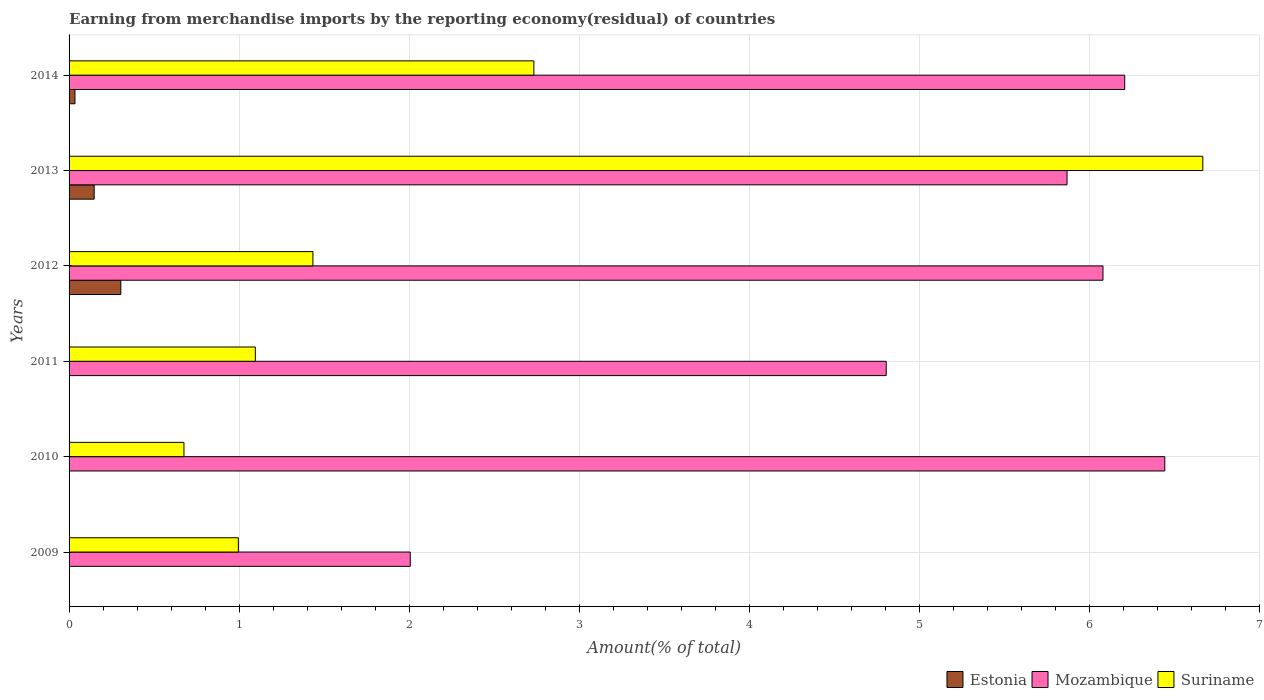How many different coloured bars are there?
Make the answer very short. 3. How many groups of bars are there?
Offer a very short reply. 6. Are the number of bars on each tick of the Y-axis equal?
Make the answer very short. Yes. What is the percentage of amount earned from merchandise imports in Estonia in 2009?
Provide a succinct answer. 0. Across all years, what is the maximum percentage of amount earned from merchandise imports in Suriname?
Provide a succinct answer. 6.67. Across all years, what is the minimum percentage of amount earned from merchandise imports in Suriname?
Give a very brief answer. 0.68. In which year was the percentage of amount earned from merchandise imports in Estonia maximum?
Offer a terse response. 2012. What is the total percentage of amount earned from merchandise imports in Mozambique in the graph?
Offer a very short reply. 31.42. What is the difference between the percentage of amount earned from merchandise imports in Suriname in 2010 and that in 2013?
Provide a short and direct response. -5.99. What is the difference between the percentage of amount earned from merchandise imports in Mozambique in 2010 and the percentage of amount earned from merchandise imports in Suriname in 2012?
Provide a short and direct response. 5.01. What is the average percentage of amount earned from merchandise imports in Estonia per year?
Provide a succinct answer. 0.08. In the year 2013, what is the difference between the percentage of amount earned from merchandise imports in Suriname and percentage of amount earned from merchandise imports in Mozambique?
Provide a succinct answer. 0.8. What is the ratio of the percentage of amount earned from merchandise imports in Suriname in 2009 to that in 2013?
Keep it short and to the point. 0.15. What is the difference between the highest and the second highest percentage of amount earned from merchandise imports in Estonia?
Give a very brief answer. 0.16. What is the difference between the highest and the lowest percentage of amount earned from merchandise imports in Mozambique?
Offer a very short reply. 4.44. In how many years, is the percentage of amount earned from merchandise imports in Mozambique greater than the average percentage of amount earned from merchandise imports in Mozambique taken over all years?
Offer a very short reply. 4. What does the 2nd bar from the top in 2014 represents?
Ensure brevity in your answer.  Mozambique. What does the 1st bar from the bottom in 2011 represents?
Offer a terse response. Estonia. Is it the case that in every year, the sum of the percentage of amount earned from merchandise imports in Estonia and percentage of amount earned from merchandise imports in Suriname is greater than the percentage of amount earned from merchandise imports in Mozambique?
Offer a terse response. No. How many bars are there?
Offer a terse response. 18. Are all the bars in the graph horizontal?
Ensure brevity in your answer.  Yes. How many years are there in the graph?
Offer a terse response. 6. What is the difference between two consecutive major ticks on the X-axis?
Your answer should be very brief. 1. Does the graph contain grids?
Offer a terse response. Yes. How many legend labels are there?
Ensure brevity in your answer.  3. What is the title of the graph?
Ensure brevity in your answer.  Earning from merchandise imports by the reporting economy(residual) of countries. Does "Barbados" appear as one of the legend labels in the graph?
Offer a terse response. No. What is the label or title of the X-axis?
Offer a terse response. Amount(% of total). What is the Amount(% of total) of Estonia in 2009?
Offer a terse response. 0. What is the Amount(% of total) in Mozambique in 2009?
Keep it short and to the point. 2.01. What is the Amount(% of total) in Suriname in 2009?
Provide a short and direct response. 1. What is the Amount(% of total) in Estonia in 2010?
Your answer should be very brief. 2.66567306426196e-5. What is the Amount(% of total) of Mozambique in 2010?
Ensure brevity in your answer.  6.45. What is the Amount(% of total) of Suriname in 2010?
Make the answer very short. 0.68. What is the Amount(% of total) in Estonia in 2011?
Offer a very short reply. 0. What is the Amount(% of total) in Mozambique in 2011?
Your answer should be compact. 4.81. What is the Amount(% of total) of Suriname in 2011?
Ensure brevity in your answer.  1.1. What is the Amount(% of total) of Estonia in 2012?
Your answer should be very brief. 0.3. What is the Amount(% of total) in Mozambique in 2012?
Offer a terse response. 6.08. What is the Amount(% of total) of Suriname in 2012?
Keep it short and to the point. 1.43. What is the Amount(% of total) of Estonia in 2013?
Provide a short and direct response. 0.15. What is the Amount(% of total) in Mozambique in 2013?
Provide a short and direct response. 5.87. What is the Amount(% of total) in Suriname in 2013?
Make the answer very short. 6.67. What is the Amount(% of total) in Estonia in 2014?
Offer a terse response. 0.03. What is the Amount(% of total) of Mozambique in 2014?
Keep it short and to the point. 6.21. What is the Amount(% of total) in Suriname in 2014?
Your answer should be compact. 2.73. Across all years, what is the maximum Amount(% of total) of Estonia?
Offer a very short reply. 0.3. Across all years, what is the maximum Amount(% of total) of Mozambique?
Your answer should be compact. 6.45. Across all years, what is the maximum Amount(% of total) of Suriname?
Your answer should be compact. 6.67. Across all years, what is the minimum Amount(% of total) in Estonia?
Offer a terse response. 2.66567306426196e-5. Across all years, what is the minimum Amount(% of total) of Mozambique?
Your answer should be very brief. 2.01. Across all years, what is the minimum Amount(% of total) of Suriname?
Ensure brevity in your answer.  0.68. What is the total Amount(% of total) in Estonia in the graph?
Your response must be concise. 0.49. What is the total Amount(% of total) in Mozambique in the graph?
Keep it short and to the point. 31.42. What is the total Amount(% of total) of Suriname in the graph?
Your response must be concise. 13.61. What is the difference between the Amount(% of total) in Mozambique in 2009 and that in 2010?
Make the answer very short. -4.44. What is the difference between the Amount(% of total) in Suriname in 2009 and that in 2010?
Your answer should be compact. 0.32. What is the difference between the Amount(% of total) of Mozambique in 2009 and that in 2011?
Provide a succinct answer. -2.8. What is the difference between the Amount(% of total) of Suriname in 2009 and that in 2011?
Your response must be concise. -0.1. What is the difference between the Amount(% of total) in Estonia in 2009 and that in 2012?
Offer a terse response. -0.3. What is the difference between the Amount(% of total) in Mozambique in 2009 and that in 2012?
Offer a terse response. -4.07. What is the difference between the Amount(% of total) in Suriname in 2009 and that in 2012?
Keep it short and to the point. -0.44. What is the difference between the Amount(% of total) in Estonia in 2009 and that in 2013?
Provide a succinct answer. -0.15. What is the difference between the Amount(% of total) of Mozambique in 2009 and that in 2013?
Offer a terse response. -3.86. What is the difference between the Amount(% of total) of Suriname in 2009 and that in 2013?
Make the answer very short. -5.67. What is the difference between the Amount(% of total) of Estonia in 2009 and that in 2014?
Give a very brief answer. -0.03. What is the difference between the Amount(% of total) of Mozambique in 2009 and that in 2014?
Make the answer very short. -4.2. What is the difference between the Amount(% of total) of Suriname in 2009 and that in 2014?
Make the answer very short. -1.74. What is the difference between the Amount(% of total) of Estonia in 2010 and that in 2011?
Offer a very short reply. -0. What is the difference between the Amount(% of total) of Mozambique in 2010 and that in 2011?
Offer a very short reply. 1.64. What is the difference between the Amount(% of total) of Suriname in 2010 and that in 2011?
Your answer should be compact. -0.42. What is the difference between the Amount(% of total) of Estonia in 2010 and that in 2012?
Give a very brief answer. -0.3. What is the difference between the Amount(% of total) of Mozambique in 2010 and that in 2012?
Offer a very short reply. 0.36. What is the difference between the Amount(% of total) of Suriname in 2010 and that in 2012?
Provide a succinct answer. -0.76. What is the difference between the Amount(% of total) in Estonia in 2010 and that in 2013?
Keep it short and to the point. -0.15. What is the difference between the Amount(% of total) in Mozambique in 2010 and that in 2013?
Your answer should be very brief. 0.58. What is the difference between the Amount(% of total) in Suriname in 2010 and that in 2013?
Keep it short and to the point. -5.99. What is the difference between the Amount(% of total) of Estonia in 2010 and that in 2014?
Provide a succinct answer. -0.03. What is the difference between the Amount(% of total) of Mozambique in 2010 and that in 2014?
Provide a short and direct response. 0.24. What is the difference between the Amount(% of total) in Suriname in 2010 and that in 2014?
Make the answer very short. -2.06. What is the difference between the Amount(% of total) of Estonia in 2011 and that in 2012?
Offer a terse response. -0.3. What is the difference between the Amount(% of total) in Mozambique in 2011 and that in 2012?
Your response must be concise. -1.28. What is the difference between the Amount(% of total) in Suriname in 2011 and that in 2012?
Make the answer very short. -0.34. What is the difference between the Amount(% of total) of Estonia in 2011 and that in 2013?
Your response must be concise. -0.15. What is the difference between the Amount(% of total) of Mozambique in 2011 and that in 2013?
Keep it short and to the point. -1.06. What is the difference between the Amount(% of total) in Suriname in 2011 and that in 2013?
Offer a very short reply. -5.57. What is the difference between the Amount(% of total) of Estonia in 2011 and that in 2014?
Ensure brevity in your answer.  -0.03. What is the difference between the Amount(% of total) in Mozambique in 2011 and that in 2014?
Offer a very short reply. -1.4. What is the difference between the Amount(% of total) of Suriname in 2011 and that in 2014?
Your answer should be very brief. -1.64. What is the difference between the Amount(% of total) in Estonia in 2012 and that in 2013?
Offer a very short reply. 0.16. What is the difference between the Amount(% of total) in Mozambique in 2012 and that in 2013?
Keep it short and to the point. 0.21. What is the difference between the Amount(% of total) of Suriname in 2012 and that in 2013?
Your answer should be very brief. -5.23. What is the difference between the Amount(% of total) in Estonia in 2012 and that in 2014?
Your answer should be compact. 0.27. What is the difference between the Amount(% of total) of Mozambique in 2012 and that in 2014?
Make the answer very short. -0.13. What is the difference between the Amount(% of total) of Suriname in 2012 and that in 2014?
Provide a succinct answer. -1.3. What is the difference between the Amount(% of total) in Estonia in 2013 and that in 2014?
Provide a succinct answer. 0.11. What is the difference between the Amount(% of total) in Mozambique in 2013 and that in 2014?
Your answer should be very brief. -0.34. What is the difference between the Amount(% of total) in Suriname in 2013 and that in 2014?
Ensure brevity in your answer.  3.94. What is the difference between the Amount(% of total) of Estonia in 2009 and the Amount(% of total) of Mozambique in 2010?
Keep it short and to the point. -6.45. What is the difference between the Amount(% of total) in Estonia in 2009 and the Amount(% of total) in Suriname in 2010?
Offer a terse response. -0.68. What is the difference between the Amount(% of total) of Mozambique in 2009 and the Amount(% of total) of Suriname in 2010?
Ensure brevity in your answer.  1.33. What is the difference between the Amount(% of total) in Estonia in 2009 and the Amount(% of total) in Mozambique in 2011?
Provide a succinct answer. -4.81. What is the difference between the Amount(% of total) in Estonia in 2009 and the Amount(% of total) in Suriname in 2011?
Offer a terse response. -1.1. What is the difference between the Amount(% of total) of Mozambique in 2009 and the Amount(% of total) of Suriname in 2011?
Ensure brevity in your answer.  0.91. What is the difference between the Amount(% of total) of Estonia in 2009 and the Amount(% of total) of Mozambique in 2012?
Give a very brief answer. -6.08. What is the difference between the Amount(% of total) of Estonia in 2009 and the Amount(% of total) of Suriname in 2012?
Offer a terse response. -1.43. What is the difference between the Amount(% of total) in Mozambique in 2009 and the Amount(% of total) in Suriname in 2012?
Make the answer very short. 0.57. What is the difference between the Amount(% of total) of Estonia in 2009 and the Amount(% of total) of Mozambique in 2013?
Offer a terse response. -5.87. What is the difference between the Amount(% of total) of Estonia in 2009 and the Amount(% of total) of Suriname in 2013?
Offer a very short reply. -6.67. What is the difference between the Amount(% of total) in Mozambique in 2009 and the Amount(% of total) in Suriname in 2013?
Your answer should be compact. -4.66. What is the difference between the Amount(% of total) in Estonia in 2009 and the Amount(% of total) in Mozambique in 2014?
Give a very brief answer. -6.21. What is the difference between the Amount(% of total) of Estonia in 2009 and the Amount(% of total) of Suriname in 2014?
Keep it short and to the point. -2.73. What is the difference between the Amount(% of total) in Mozambique in 2009 and the Amount(% of total) in Suriname in 2014?
Ensure brevity in your answer.  -0.73. What is the difference between the Amount(% of total) in Estonia in 2010 and the Amount(% of total) in Mozambique in 2011?
Keep it short and to the point. -4.81. What is the difference between the Amount(% of total) of Estonia in 2010 and the Amount(% of total) of Suriname in 2011?
Your answer should be compact. -1.1. What is the difference between the Amount(% of total) of Mozambique in 2010 and the Amount(% of total) of Suriname in 2011?
Offer a very short reply. 5.35. What is the difference between the Amount(% of total) in Estonia in 2010 and the Amount(% of total) in Mozambique in 2012?
Provide a short and direct response. -6.08. What is the difference between the Amount(% of total) of Estonia in 2010 and the Amount(% of total) of Suriname in 2012?
Give a very brief answer. -1.43. What is the difference between the Amount(% of total) of Mozambique in 2010 and the Amount(% of total) of Suriname in 2012?
Provide a short and direct response. 5.01. What is the difference between the Amount(% of total) in Estonia in 2010 and the Amount(% of total) in Mozambique in 2013?
Ensure brevity in your answer.  -5.87. What is the difference between the Amount(% of total) of Estonia in 2010 and the Amount(% of total) of Suriname in 2013?
Your response must be concise. -6.67. What is the difference between the Amount(% of total) in Mozambique in 2010 and the Amount(% of total) in Suriname in 2013?
Offer a very short reply. -0.22. What is the difference between the Amount(% of total) in Estonia in 2010 and the Amount(% of total) in Mozambique in 2014?
Provide a short and direct response. -6.21. What is the difference between the Amount(% of total) in Estonia in 2010 and the Amount(% of total) in Suriname in 2014?
Offer a very short reply. -2.73. What is the difference between the Amount(% of total) in Mozambique in 2010 and the Amount(% of total) in Suriname in 2014?
Provide a succinct answer. 3.71. What is the difference between the Amount(% of total) of Estonia in 2011 and the Amount(% of total) of Mozambique in 2012?
Ensure brevity in your answer.  -6.08. What is the difference between the Amount(% of total) in Estonia in 2011 and the Amount(% of total) in Suriname in 2012?
Your answer should be compact. -1.43. What is the difference between the Amount(% of total) in Mozambique in 2011 and the Amount(% of total) in Suriname in 2012?
Offer a terse response. 3.37. What is the difference between the Amount(% of total) of Estonia in 2011 and the Amount(% of total) of Mozambique in 2013?
Offer a very short reply. -5.87. What is the difference between the Amount(% of total) of Estonia in 2011 and the Amount(% of total) of Suriname in 2013?
Give a very brief answer. -6.67. What is the difference between the Amount(% of total) in Mozambique in 2011 and the Amount(% of total) in Suriname in 2013?
Ensure brevity in your answer.  -1.86. What is the difference between the Amount(% of total) of Estonia in 2011 and the Amount(% of total) of Mozambique in 2014?
Keep it short and to the point. -6.21. What is the difference between the Amount(% of total) of Estonia in 2011 and the Amount(% of total) of Suriname in 2014?
Offer a very short reply. -2.73. What is the difference between the Amount(% of total) of Mozambique in 2011 and the Amount(% of total) of Suriname in 2014?
Ensure brevity in your answer.  2.07. What is the difference between the Amount(% of total) in Estonia in 2012 and the Amount(% of total) in Mozambique in 2013?
Keep it short and to the point. -5.57. What is the difference between the Amount(% of total) of Estonia in 2012 and the Amount(% of total) of Suriname in 2013?
Provide a succinct answer. -6.36. What is the difference between the Amount(% of total) in Mozambique in 2012 and the Amount(% of total) in Suriname in 2013?
Provide a short and direct response. -0.59. What is the difference between the Amount(% of total) in Estonia in 2012 and the Amount(% of total) in Mozambique in 2014?
Ensure brevity in your answer.  -5.91. What is the difference between the Amount(% of total) of Estonia in 2012 and the Amount(% of total) of Suriname in 2014?
Keep it short and to the point. -2.43. What is the difference between the Amount(% of total) of Mozambique in 2012 and the Amount(% of total) of Suriname in 2014?
Give a very brief answer. 3.35. What is the difference between the Amount(% of total) of Estonia in 2013 and the Amount(% of total) of Mozambique in 2014?
Keep it short and to the point. -6.06. What is the difference between the Amount(% of total) of Estonia in 2013 and the Amount(% of total) of Suriname in 2014?
Offer a very short reply. -2.59. What is the difference between the Amount(% of total) in Mozambique in 2013 and the Amount(% of total) in Suriname in 2014?
Offer a terse response. 3.14. What is the average Amount(% of total) of Estonia per year?
Make the answer very short. 0.08. What is the average Amount(% of total) in Mozambique per year?
Provide a succinct answer. 5.24. What is the average Amount(% of total) of Suriname per year?
Provide a short and direct response. 2.27. In the year 2009, what is the difference between the Amount(% of total) of Estonia and Amount(% of total) of Mozambique?
Your answer should be compact. -2.01. In the year 2009, what is the difference between the Amount(% of total) in Estonia and Amount(% of total) in Suriname?
Offer a terse response. -1. In the year 2009, what is the difference between the Amount(% of total) of Mozambique and Amount(% of total) of Suriname?
Your answer should be compact. 1.01. In the year 2010, what is the difference between the Amount(% of total) in Estonia and Amount(% of total) in Mozambique?
Your answer should be compact. -6.45. In the year 2010, what is the difference between the Amount(% of total) in Estonia and Amount(% of total) in Suriname?
Provide a succinct answer. -0.68. In the year 2010, what is the difference between the Amount(% of total) of Mozambique and Amount(% of total) of Suriname?
Ensure brevity in your answer.  5.77. In the year 2011, what is the difference between the Amount(% of total) in Estonia and Amount(% of total) in Mozambique?
Provide a short and direct response. -4.81. In the year 2011, what is the difference between the Amount(% of total) in Estonia and Amount(% of total) in Suriname?
Provide a short and direct response. -1.1. In the year 2011, what is the difference between the Amount(% of total) in Mozambique and Amount(% of total) in Suriname?
Your answer should be very brief. 3.71. In the year 2012, what is the difference between the Amount(% of total) of Estonia and Amount(% of total) of Mozambique?
Offer a very short reply. -5.78. In the year 2012, what is the difference between the Amount(% of total) in Estonia and Amount(% of total) in Suriname?
Provide a succinct answer. -1.13. In the year 2012, what is the difference between the Amount(% of total) of Mozambique and Amount(% of total) of Suriname?
Your answer should be very brief. 4.65. In the year 2013, what is the difference between the Amount(% of total) of Estonia and Amount(% of total) of Mozambique?
Give a very brief answer. -5.72. In the year 2013, what is the difference between the Amount(% of total) of Estonia and Amount(% of total) of Suriname?
Provide a short and direct response. -6.52. In the year 2013, what is the difference between the Amount(% of total) in Mozambique and Amount(% of total) in Suriname?
Ensure brevity in your answer.  -0.8. In the year 2014, what is the difference between the Amount(% of total) of Estonia and Amount(% of total) of Mozambique?
Make the answer very short. -6.18. In the year 2014, what is the difference between the Amount(% of total) in Estonia and Amount(% of total) in Suriname?
Give a very brief answer. -2.7. In the year 2014, what is the difference between the Amount(% of total) of Mozambique and Amount(% of total) of Suriname?
Ensure brevity in your answer.  3.48. What is the ratio of the Amount(% of total) in Estonia in 2009 to that in 2010?
Make the answer very short. 8.24. What is the ratio of the Amount(% of total) in Mozambique in 2009 to that in 2010?
Provide a short and direct response. 0.31. What is the ratio of the Amount(% of total) of Suriname in 2009 to that in 2010?
Your answer should be compact. 1.47. What is the ratio of the Amount(% of total) of Estonia in 2009 to that in 2011?
Give a very brief answer. 1.29. What is the ratio of the Amount(% of total) of Mozambique in 2009 to that in 2011?
Ensure brevity in your answer.  0.42. What is the ratio of the Amount(% of total) of Suriname in 2009 to that in 2011?
Make the answer very short. 0.91. What is the ratio of the Amount(% of total) in Estonia in 2009 to that in 2012?
Your response must be concise. 0. What is the ratio of the Amount(% of total) in Mozambique in 2009 to that in 2012?
Ensure brevity in your answer.  0.33. What is the ratio of the Amount(% of total) of Suriname in 2009 to that in 2012?
Give a very brief answer. 0.69. What is the ratio of the Amount(% of total) of Estonia in 2009 to that in 2013?
Your response must be concise. 0. What is the ratio of the Amount(% of total) of Mozambique in 2009 to that in 2013?
Offer a terse response. 0.34. What is the ratio of the Amount(% of total) of Suriname in 2009 to that in 2013?
Offer a very short reply. 0.15. What is the ratio of the Amount(% of total) of Estonia in 2009 to that in 2014?
Your answer should be compact. 0.01. What is the ratio of the Amount(% of total) in Mozambique in 2009 to that in 2014?
Provide a succinct answer. 0.32. What is the ratio of the Amount(% of total) in Suriname in 2009 to that in 2014?
Make the answer very short. 0.36. What is the ratio of the Amount(% of total) in Estonia in 2010 to that in 2011?
Give a very brief answer. 0.16. What is the ratio of the Amount(% of total) of Mozambique in 2010 to that in 2011?
Offer a very short reply. 1.34. What is the ratio of the Amount(% of total) in Suriname in 2010 to that in 2011?
Provide a short and direct response. 0.62. What is the ratio of the Amount(% of total) in Mozambique in 2010 to that in 2012?
Keep it short and to the point. 1.06. What is the ratio of the Amount(% of total) of Suriname in 2010 to that in 2012?
Make the answer very short. 0.47. What is the ratio of the Amount(% of total) of Mozambique in 2010 to that in 2013?
Make the answer very short. 1.1. What is the ratio of the Amount(% of total) in Suriname in 2010 to that in 2013?
Make the answer very short. 0.1. What is the ratio of the Amount(% of total) in Estonia in 2010 to that in 2014?
Offer a terse response. 0. What is the ratio of the Amount(% of total) in Mozambique in 2010 to that in 2014?
Your response must be concise. 1.04. What is the ratio of the Amount(% of total) of Suriname in 2010 to that in 2014?
Provide a short and direct response. 0.25. What is the ratio of the Amount(% of total) in Estonia in 2011 to that in 2012?
Make the answer very short. 0. What is the ratio of the Amount(% of total) of Mozambique in 2011 to that in 2012?
Provide a short and direct response. 0.79. What is the ratio of the Amount(% of total) of Suriname in 2011 to that in 2012?
Ensure brevity in your answer.  0.76. What is the ratio of the Amount(% of total) of Estonia in 2011 to that in 2013?
Offer a very short reply. 0. What is the ratio of the Amount(% of total) in Mozambique in 2011 to that in 2013?
Make the answer very short. 0.82. What is the ratio of the Amount(% of total) of Suriname in 2011 to that in 2013?
Offer a very short reply. 0.16. What is the ratio of the Amount(% of total) of Estonia in 2011 to that in 2014?
Your answer should be very brief. 0. What is the ratio of the Amount(% of total) in Mozambique in 2011 to that in 2014?
Ensure brevity in your answer.  0.77. What is the ratio of the Amount(% of total) in Suriname in 2011 to that in 2014?
Provide a succinct answer. 0.4. What is the ratio of the Amount(% of total) of Estonia in 2012 to that in 2013?
Provide a succinct answer. 2.06. What is the ratio of the Amount(% of total) of Mozambique in 2012 to that in 2013?
Ensure brevity in your answer.  1.04. What is the ratio of the Amount(% of total) in Suriname in 2012 to that in 2013?
Provide a succinct answer. 0.22. What is the ratio of the Amount(% of total) of Estonia in 2012 to that in 2014?
Your answer should be compact. 8.8. What is the ratio of the Amount(% of total) in Mozambique in 2012 to that in 2014?
Your answer should be very brief. 0.98. What is the ratio of the Amount(% of total) in Suriname in 2012 to that in 2014?
Your answer should be very brief. 0.52. What is the ratio of the Amount(% of total) of Estonia in 2013 to that in 2014?
Keep it short and to the point. 4.27. What is the ratio of the Amount(% of total) in Mozambique in 2013 to that in 2014?
Keep it short and to the point. 0.95. What is the ratio of the Amount(% of total) in Suriname in 2013 to that in 2014?
Your answer should be compact. 2.44. What is the difference between the highest and the second highest Amount(% of total) of Estonia?
Give a very brief answer. 0.16. What is the difference between the highest and the second highest Amount(% of total) in Mozambique?
Your answer should be very brief. 0.24. What is the difference between the highest and the second highest Amount(% of total) of Suriname?
Your answer should be very brief. 3.94. What is the difference between the highest and the lowest Amount(% of total) of Estonia?
Keep it short and to the point. 0.3. What is the difference between the highest and the lowest Amount(% of total) of Mozambique?
Ensure brevity in your answer.  4.44. What is the difference between the highest and the lowest Amount(% of total) of Suriname?
Your response must be concise. 5.99. 